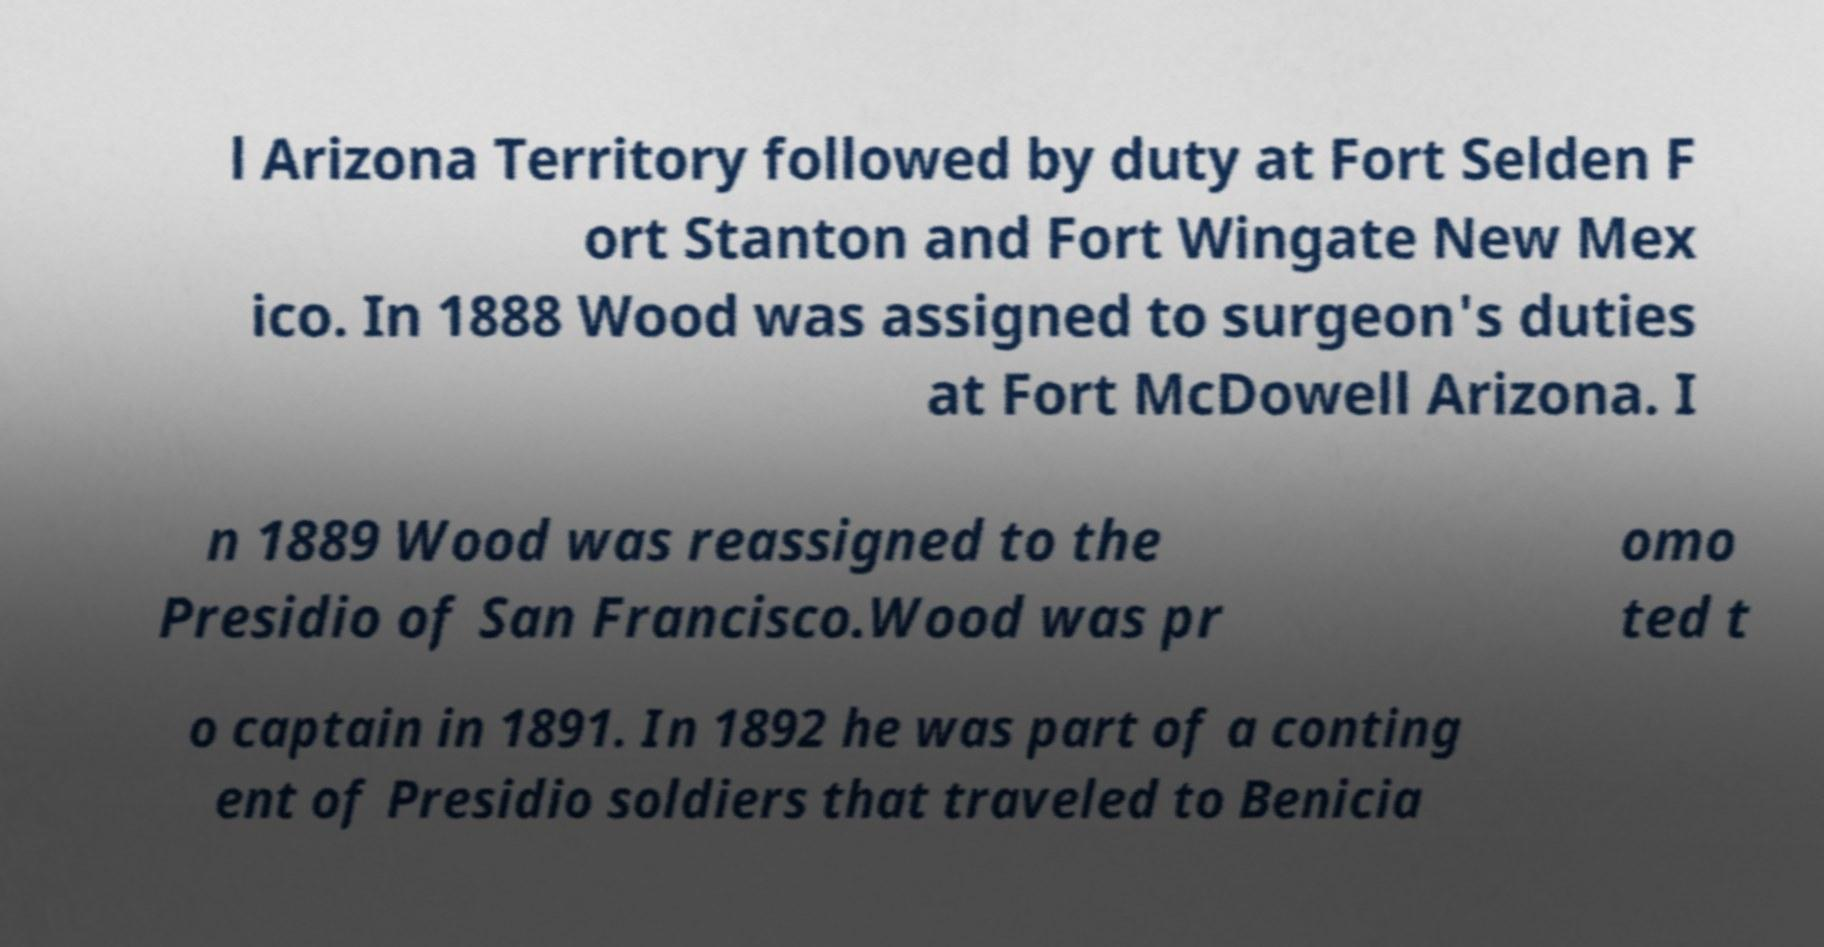What messages or text are displayed in this image? I need them in a readable, typed format. l Arizona Territory followed by duty at Fort Selden F ort Stanton and Fort Wingate New Mex ico. In 1888 Wood was assigned to surgeon's duties at Fort McDowell Arizona. I n 1889 Wood was reassigned to the Presidio of San Francisco.Wood was pr omo ted t o captain in 1891. In 1892 he was part of a conting ent of Presidio soldiers that traveled to Benicia 